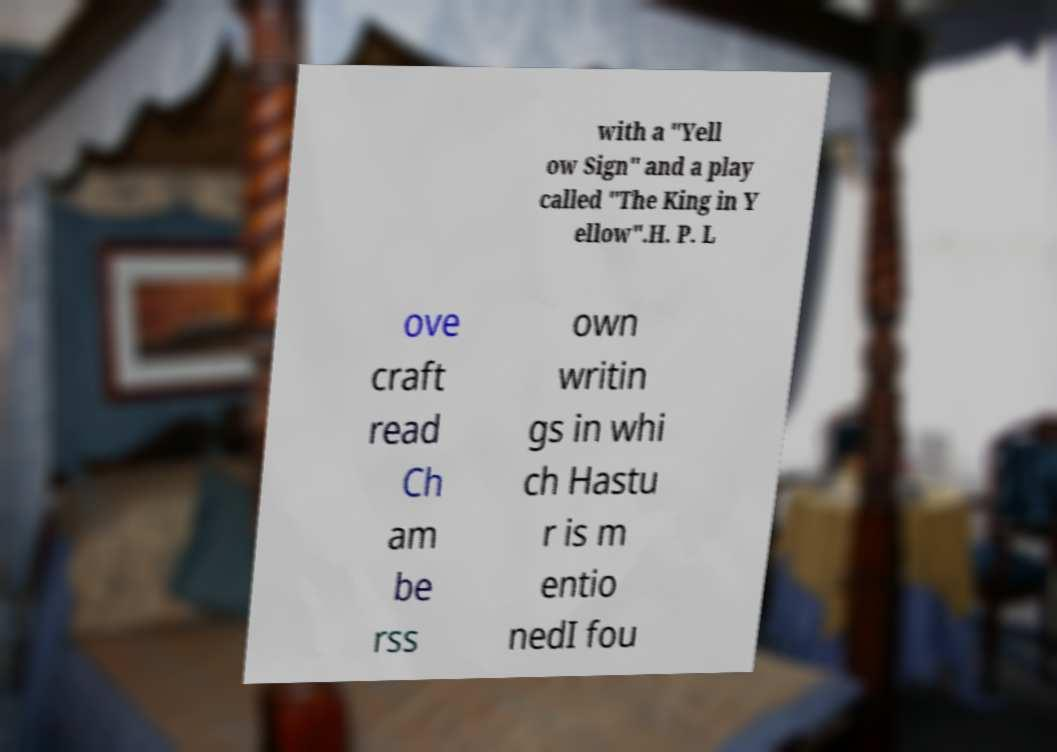Please read and relay the text visible in this image. What does it say? with a "Yell ow Sign" and a play called "The King in Y ellow".H. P. L ove craft read Ch am be rss own writin gs in whi ch Hastu r is m entio nedI fou 